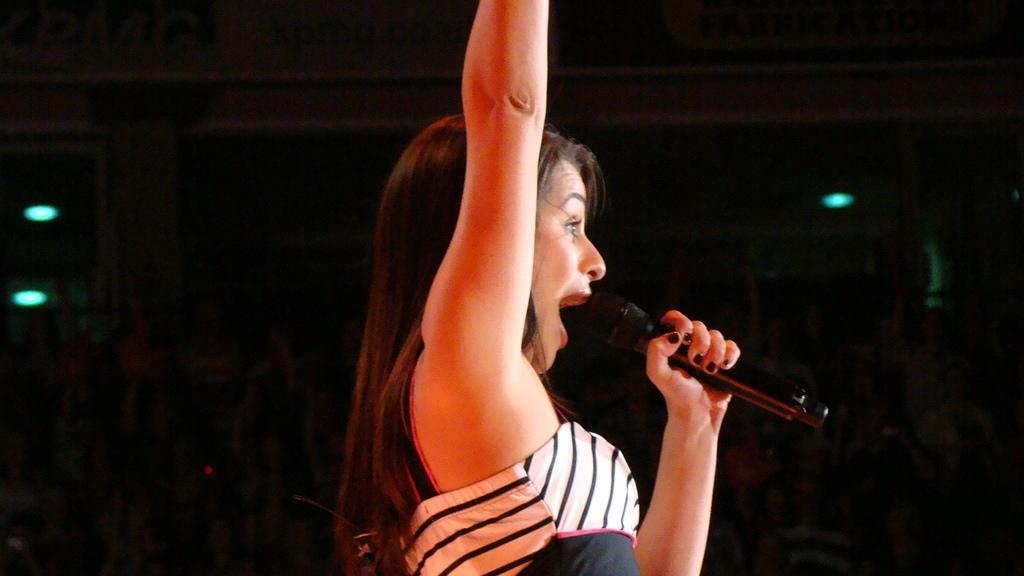In one or two sentences, can you explain what this image depicts? In the picture there is a woman catching a microphone, there may be lights present on the roof. 